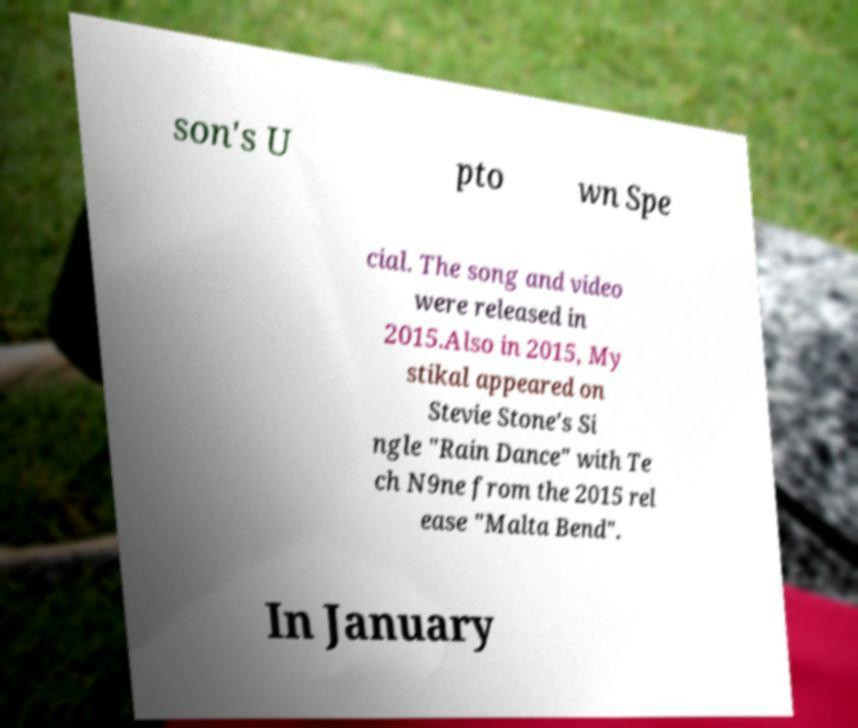There's text embedded in this image that I need extracted. Can you transcribe it verbatim? son's U pto wn Spe cial. The song and video were released in 2015.Also in 2015, My stikal appeared on Stevie Stone's Si ngle "Rain Dance" with Te ch N9ne from the 2015 rel ease "Malta Bend". In January 